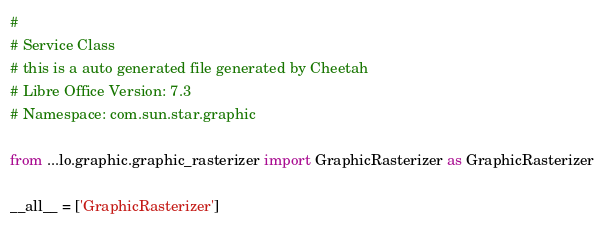Convert code to text. <code><loc_0><loc_0><loc_500><loc_500><_Python_>#
# Service Class
# this is a auto generated file generated by Cheetah
# Libre Office Version: 7.3
# Namespace: com.sun.star.graphic

from ...lo.graphic.graphic_rasterizer import GraphicRasterizer as GraphicRasterizer

__all__ = ['GraphicRasterizer']

</code> 